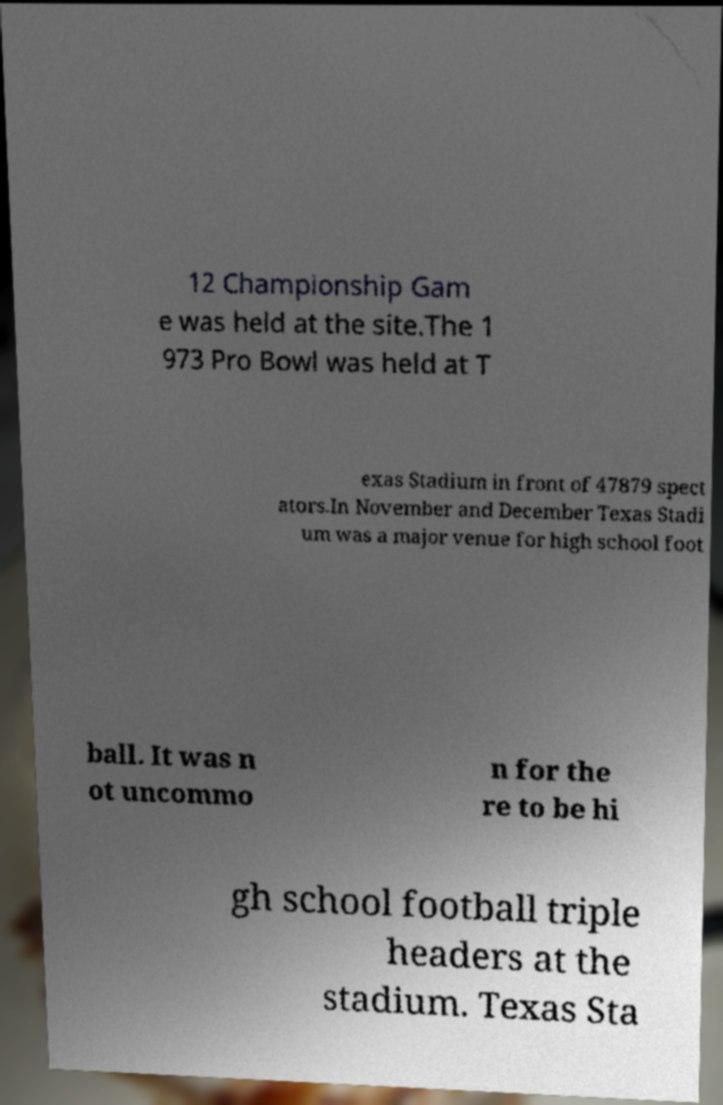Could you extract and type out the text from this image? 12 Championship Gam e was held at the site.The 1 973 Pro Bowl was held at T exas Stadium in front of 47879 spect ators.In November and December Texas Stadi um was a major venue for high school foot ball. It was n ot uncommo n for the re to be hi gh school football triple headers at the stadium. Texas Sta 